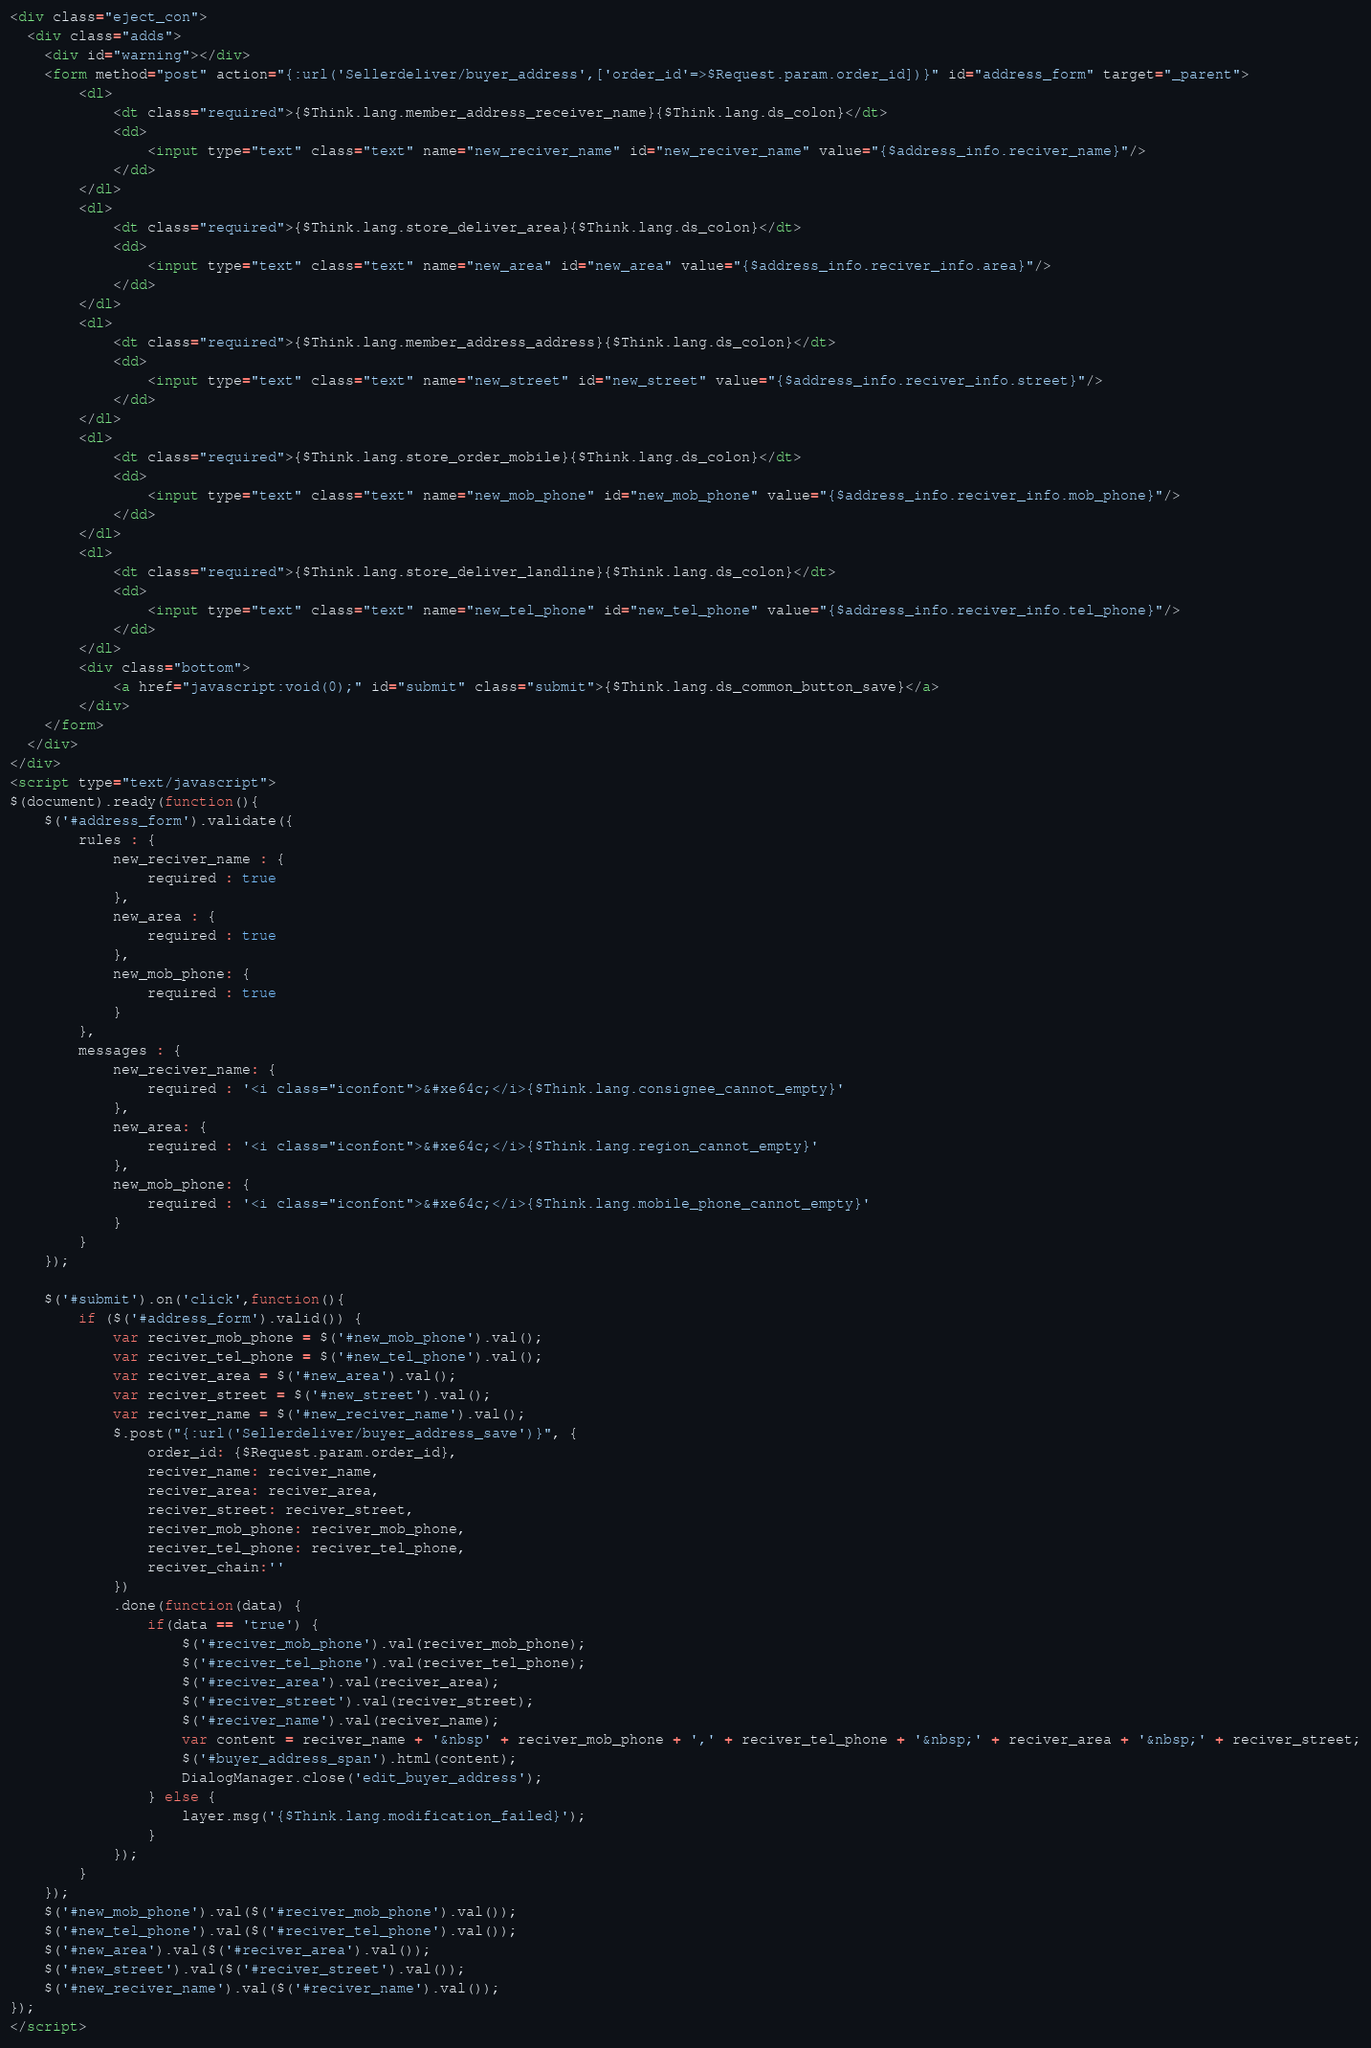<code> <loc_0><loc_0><loc_500><loc_500><_HTML_>
<div class="eject_con">
  <div class="adds">
    <div id="warning"></div>
    <form method="post" action="{:url('Sellerdeliver/buyer_address',['order_id'=>$Request.param.order_id])}" id="address_form" target="_parent">
        <dl>
            <dt class="required">{$Think.lang.member_address_receiver_name}{$Think.lang.ds_colon}</dt>
            <dd>
                <input type="text" class="text" name="new_reciver_name" id="new_reciver_name" value="{$address_info.reciver_name}"/>
            </dd>
        </dl>
        <dl>
            <dt class="required">{$Think.lang.store_deliver_area}{$Think.lang.ds_colon}</dt>
            <dd>
                <input type="text" class="text" name="new_area" id="new_area" value="{$address_info.reciver_info.area}"/>
            </dd>
        </dl>
        <dl>
            <dt class="required">{$Think.lang.member_address_address}{$Think.lang.ds_colon}</dt>
            <dd>
                <input type="text" class="text" name="new_street" id="new_street" value="{$address_info.reciver_info.street}"/>
            </dd>
        </dl>
        <dl>
            <dt class="required">{$Think.lang.store_order_mobile}{$Think.lang.ds_colon}</dt>
            <dd>
                <input type="text" class="text" name="new_mob_phone" id="new_mob_phone" value="{$address_info.reciver_info.mob_phone}"/>
            </dd>
        </dl>
        <dl>
            <dt class="required">{$Think.lang.store_deliver_landline}{$Think.lang.ds_colon}</dt>
            <dd>
                <input type="text" class="text" name="new_tel_phone" id="new_tel_phone" value="{$address_info.reciver_info.tel_phone}"/>
            </dd>
        </dl>
        <div class="bottom">
            <a href="javascript:void(0);" id="submit" class="submit">{$Think.lang.ds_common_button_save}</a>
        </div>
    </form>
  </div>
</div>
<script type="text/javascript">
$(document).ready(function(){
    $('#address_form').validate({
        rules : {
            new_reciver_name : {
                required : true
            },
            new_area : {
                required : true
            },
            new_mob_phone: {
                required : true
            }
        },
        messages : {
            new_reciver_name: {
                required : '<i class="iconfont">&#xe64c;</i>{$Think.lang.consignee_cannot_empty}'
            },
            new_area: {
                required : '<i class="iconfont">&#xe64c;</i>{$Think.lang.region_cannot_empty}'
            },
            new_mob_phone: {
                required : '<i class="iconfont">&#xe64c;</i>{$Think.lang.mobile_phone_cannot_empty}'
            }
        }
    });
   
	$('#submit').on('click',function(){
		if ($('#address_form').valid()) {
            var reciver_mob_phone = $('#new_mob_phone').val();
            var reciver_tel_phone = $('#new_tel_phone').val();
            var reciver_area = $('#new_area').val();
            var reciver_street = $('#new_street').val();
            var reciver_name = $('#new_reciver_name').val();
            $.post("{:url('Sellerdeliver/buyer_address_save')}", {
                order_id: {$Request.param.order_id},
                reciver_name: reciver_name,
                reciver_area: reciver_area,
                reciver_street: reciver_street,
                reciver_mob_phone: reciver_mob_phone,
                reciver_tel_phone: reciver_tel_phone,
                reciver_chain:''
            })
            .done(function(data) {
                if(data == 'true') {
                    $('#reciver_mob_phone').val(reciver_mob_phone);
                    $('#reciver_tel_phone').val(reciver_tel_phone);
                    $('#reciver_area').val(reciver_area);
                    $('#reciver_street').val(reciver_street);
                    $('#reciver_name').val(reciver_name);
                    var content = reciver_name + '&nbsp' + reciver_mob_phone + ',' + reciver_tel_phone + '&nbsp;' + reciver_area + '&nbsp;' + reciver_street;
                    $('#buyer_address_span').html(content);
                    DialogManager.close('edit_buyer_address');
                } else {
                    layer.msg('{$Think.lang.modification_failed}');
                }
            });
		}
	});
	$('#new_mob_phone').val($('#reciver_mob_phone').val());
	$('#new_tel_phone').val($('#reciver_tel_phone').val());
	$('#new_area').val($('#reciver_area').val());
	$('#new_street').val($('#reciver_street').val());
	$('#new_reciver_name').val($('#reciver_name').val());	
});
</script>
</code> 